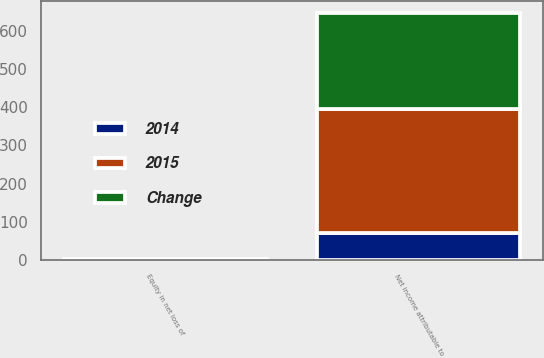Convert chart to OTSL. <chart><loc_0><loc_0><loc_500><loc_500><stacked_bar_chart><ecel><fcel>Equity in net loss of<fcel>Net income attributable to<nl><fcel>Change<fcel>1.6<fcel>251.2<nl><fcel>2015<fcel>0.4<fcel>322.9<nl><fcel>2014<fcel>1.2<fcel>71.7<nl></chart> 